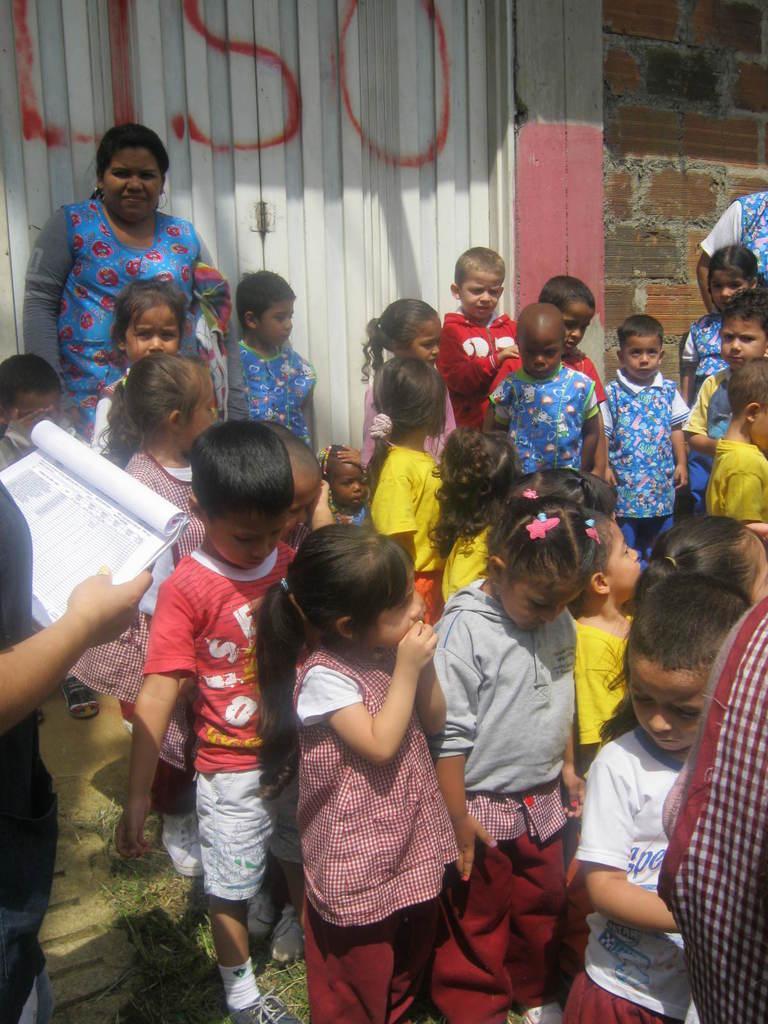How would you summarize this image in a sentence or two? In this image I can see a crowd of children standing on the ground. On the left side there is a person standing and holding a book in the hand. In the background there is a wall. 